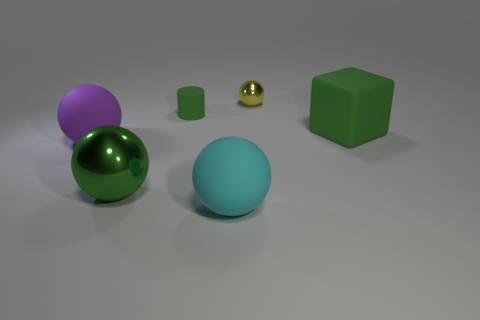There is a big rubber thing that is the same color as the rubber cylinder; what is its shape?
Provide a succinct answer. Cube. There is a green sphere; is its size the same as the yellow metallic sphere on the right side of the large shiny sphere?
Your response must be concise. No. Is there a small green object in front of the large sphere that is to the left of the big green ball?
Offer a terse response. No. There is a big object that is in front of the green matte block and on the right side of the big shiny thing; what material is it?
Ensure brevity in your answer.  Rubber. There is a metal object that is in front of the matte sphere on the left side of the matte ball right of the large purple matte ball; what is its color?
Make the answer very short. Green. The block that is the same size as the green metal thing is what color?
Your answer should be compact. Green. There is a tiny cylinder; does it have the same color as the metallic thing in front of the large green matte block?
Offer a terse response. Yes. There is a sphere that is to the left of the metallic thing in front of the large block; what is its material?
Your answer should be compact. Rubber. What number of spheres are in front of the tiny yellow object and to the right of the purple matte thing?
Your answer should be compact. 2. What number of other objects are there of the same size as the green ball?
Your answer should be compact. 3. 